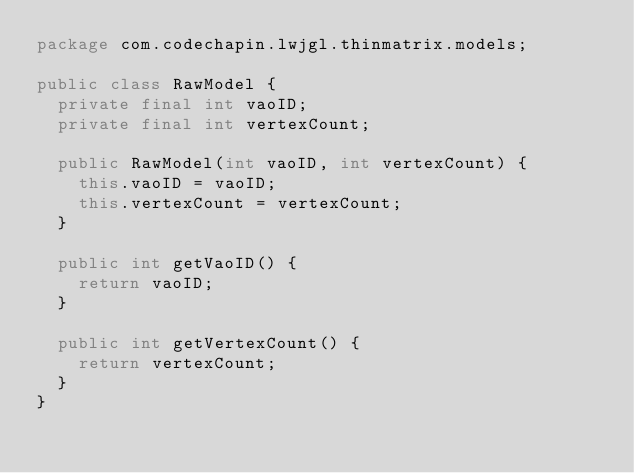Convert code to text. <code><loc_0><loc_0><loc_500><loc_500><_Java_>package com.codechapin.lwjgl.thinmatrix.models;

public class RawModel {
  private final int vaoID;
  private final int vertexCount;

  public RawModel(int vaoID, int vertexCount) {
    this.vaoID = vaoID;
    this.vertexCount = vertexCount;
  }

  public int getVaoID() {
    return vaoID;
  }

  public int getVertexCount() {
    return vertexCount;
  }
}
</code> 